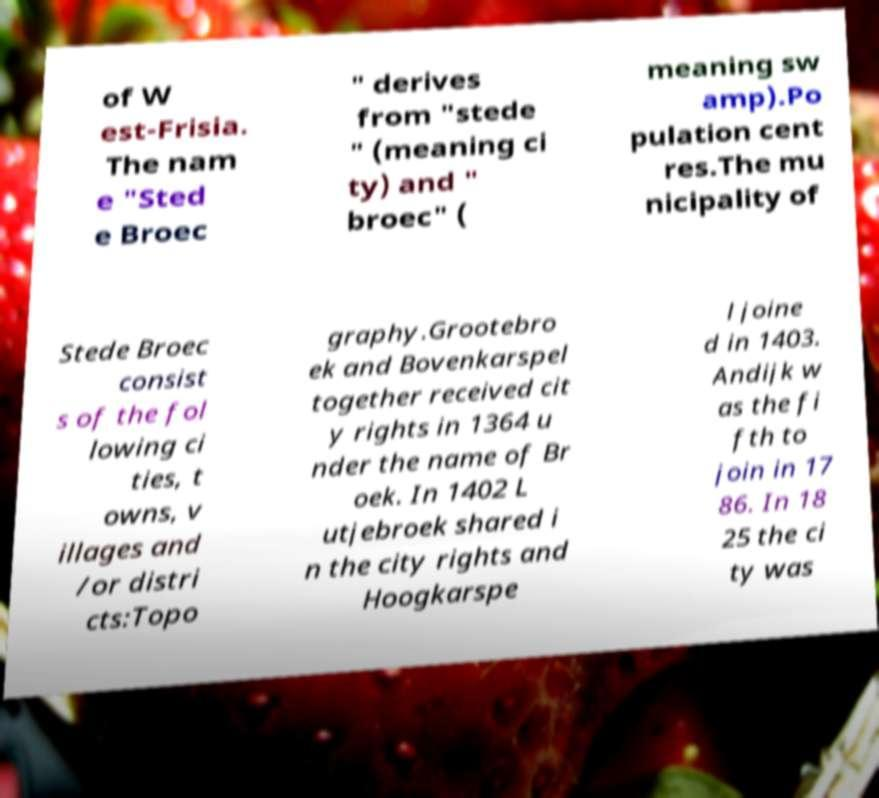For documentation purposes, I need the text within this image transcribed. Could you provide that? of W est-Frisia. The nam e "Sted e Broec " derives from "stede " (meaning ci ty) and " broec" ( meaning sw amp).Po pulation cent res.The mu nicipality of Stede Broec consist s of the fol lowing ci ties, t owns, v illages and /or distri cts:Topo graphy.Grootebro ek and Bovenkarspel together received cit y rights in 1364 u nder the name of Br oek. In 1402 L utjebroek shared i n the city rights and Hoogkarspe l joine d in 1403. Andijk w as the fi fth to join in 17 86. In 18 25 the ci ty was 